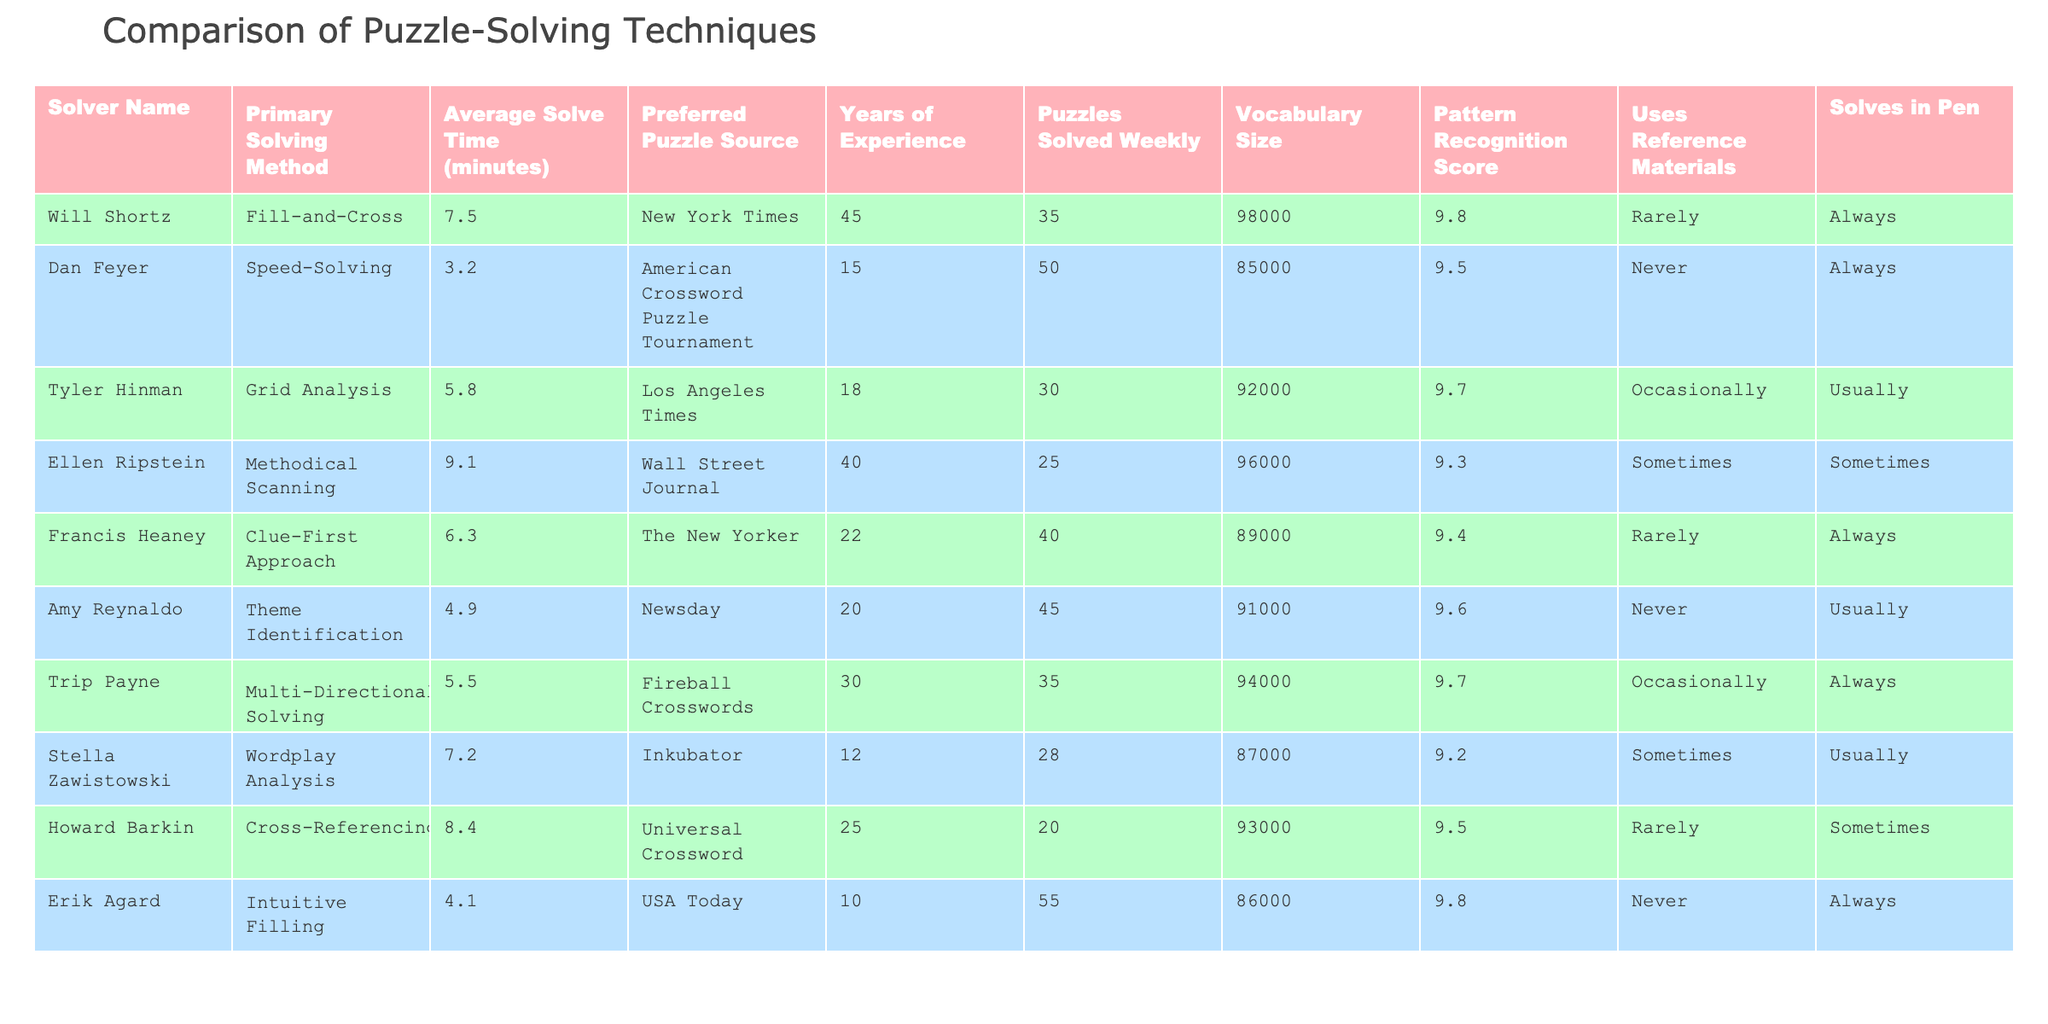What is the primary solving method used by Dan Feyer? The table lists the primary solving method for each solver. For Dan Feyer, the corresponding value in the "Primary Solving Method" column is "Speed-Solving."
Answer: Speed-Solving Who has the highest average solve time? The table shows the average solve time for each solver. By comparing the values in the "Average Solve Time (minutes)" column, Ellen Ripstein has the highest average solve time at 9.1 minutes.
Answer: Ellen Ripstein On average, how many puzzles does Tyler Hinman solve weekly? To find Tyler Hinman's weekly puzzle solving rate, look at the "Puzzles Solved Weekly" column. The value listed is 30.
Answer: 30 Is there a solver who never uses reference materials? Checking the "Uses Reference Materials" column for each solver shows that both Dan Feyer and Erik Agard never use reference materials.
Answer: Yes Who has the largest vocabulary size among the listed solvers? The table includes a "Vocabulary Size" column, where the highest value is 98,000, associated with Will Shortz.
Answer: Will Shortz What is the difference in average solve time between the fastest and slowest solvers? The fastest solver is Dan Feyer at 3.2 minutes and the slowest is Ellen Ripstein at 9.1 minutes. The difference is calculated as 9.1 - 3.2 = 5.9 minutes.
Answer: 5.9 minutes Which solver utilizes the "Clue-First Approach" and what is their years of experience? The "Primary Solving Method" column identifies Francis Heaney as the solver using the "Clue-First Approach." Looking at the "Years of Experience" column shows that Francis Heaney has 22 years of experience.
Answer: Francis Heaney, 22 years Calculate the average vocabulary size of the puzzle solvers listed. To find the average, sum the vocabulary sizes: (98000 + 85000 + 92000 + 96000 + 89000 + 91000 + 94000 + 87000 + 93000 + 86000) = 91000. Divide by the number of solvers (10): 910000/10 = 91000.
Answer: 91000 Which solving method is most commonly associated with solving in pen? The "Solves in Pen" column indicates that 6 out of 10 solvers mostly or always solve in pen. "Fill-and-Cross" by Will Shortz, "Speed-Solving" by Dan Feyer, and "Intuitive Filling" by Erik Agard are among those methods.
Answer: Fill-and-Cross, Speed-Solving, Intuitive Filling Is there a correlation between years of experience and vocabulary size among the solvers? Looking at the table, there doesn’t seem to be a clear trend. For example, Dan Feyer has 15 years of experience with a vocabulary size of 85,000, while Ellen Ripstein has 40 years with 96,000. Further analysis is needed to establish any correlation.
Answer: No clear correlation 